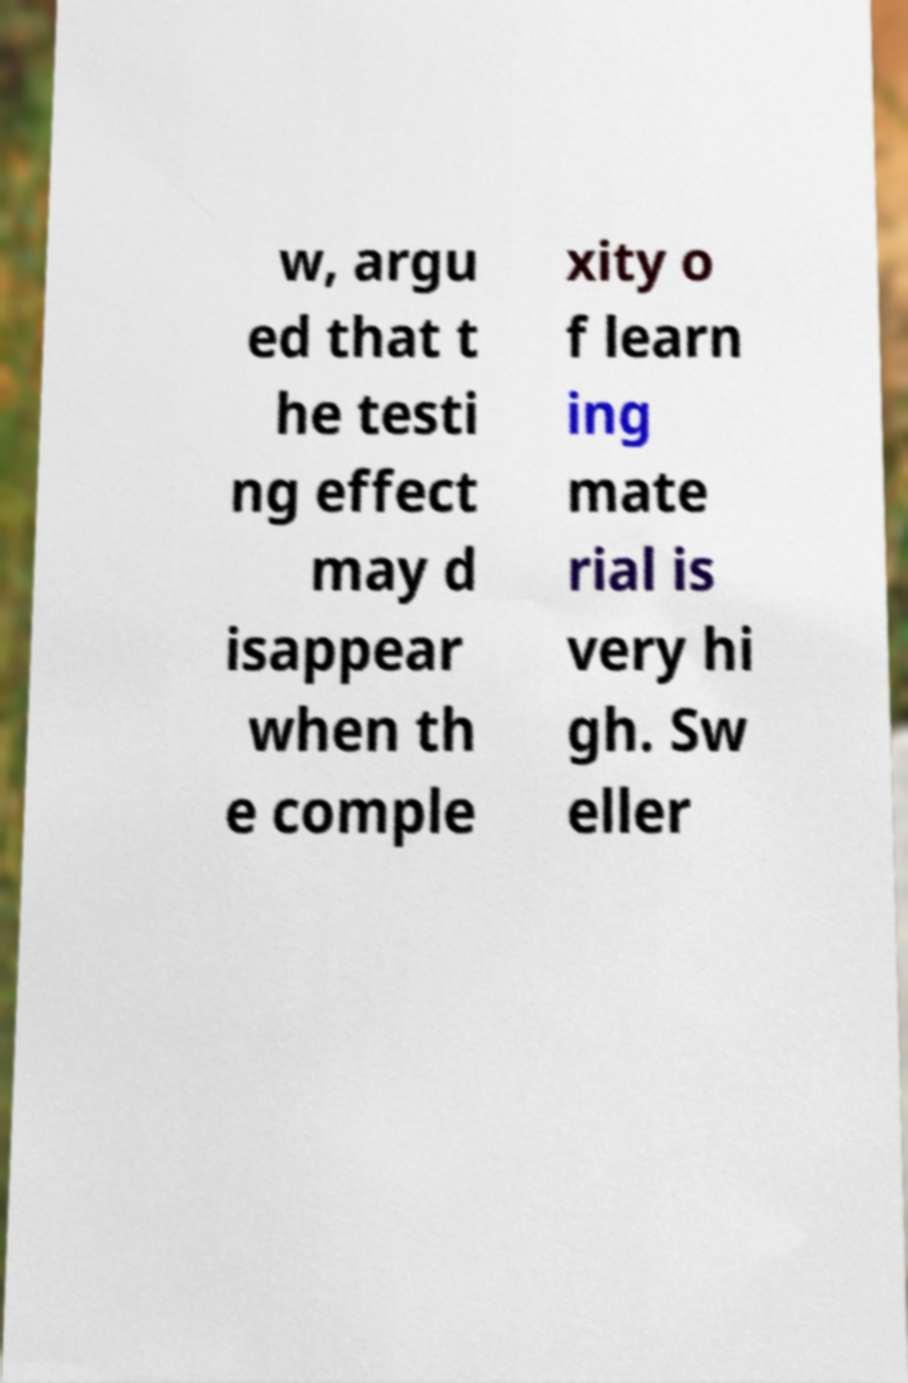For documentation purposes, I need the text within this image transcribed. Could you provide that? w, argu ed that t he testi ng effect may d isappear when th e comple xity o f learn ing mate rial is very hi gh. Sw eller 